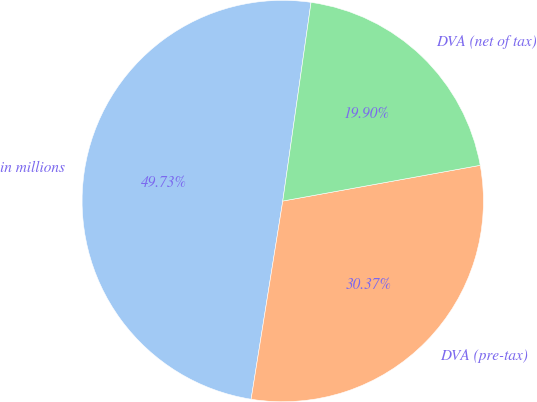Convert chart. <chart><loc_0><loc_0><loc_500><loc_500><pie_chart><fcel>in millions<fcel>DVA (pre-tax)<fcel>DVA (net of tax)<nl><fcel>49.73%<fcel>30.37%<fcel>19.9%<nl></chart> 